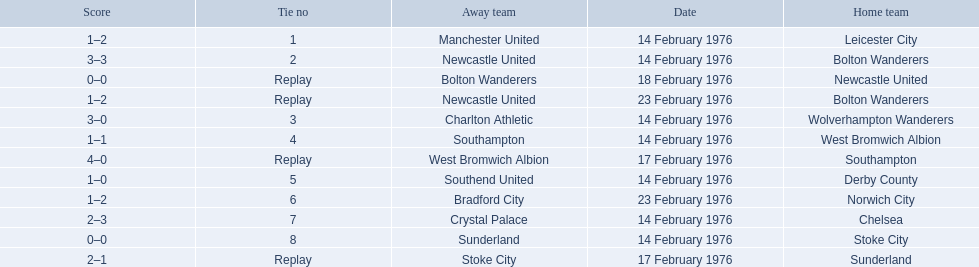Who were all the teams that played? Leicester City, Manchester United, Bolton Wanderers, Newcastle United, Newcastle United, Bolton Wanderers, Bolton Wanderers, Newcastle United, Wolverhampton Wanderers, Charlton Athletic, West Bromwich Albion, Southampton, Southampton, West Bromwich Albion, Derby County, Southend United, Norwich City, Bradford City, Chelsea, Crystal Palace, Stoke City, Sunderland, Sunderland, Stoke City. Which of these teams won? Manchester United, Newcastle United, Wolverhampton Wanderers, Southampton, Derby County, Bradford City, Crystal Palace, Sunderland. What was manchester united's winning score? 1–2. What was the wolverhampton wonders winning score? 3–0. Which of these two teams had the better winning score? Wolverhampton Wanderers. 